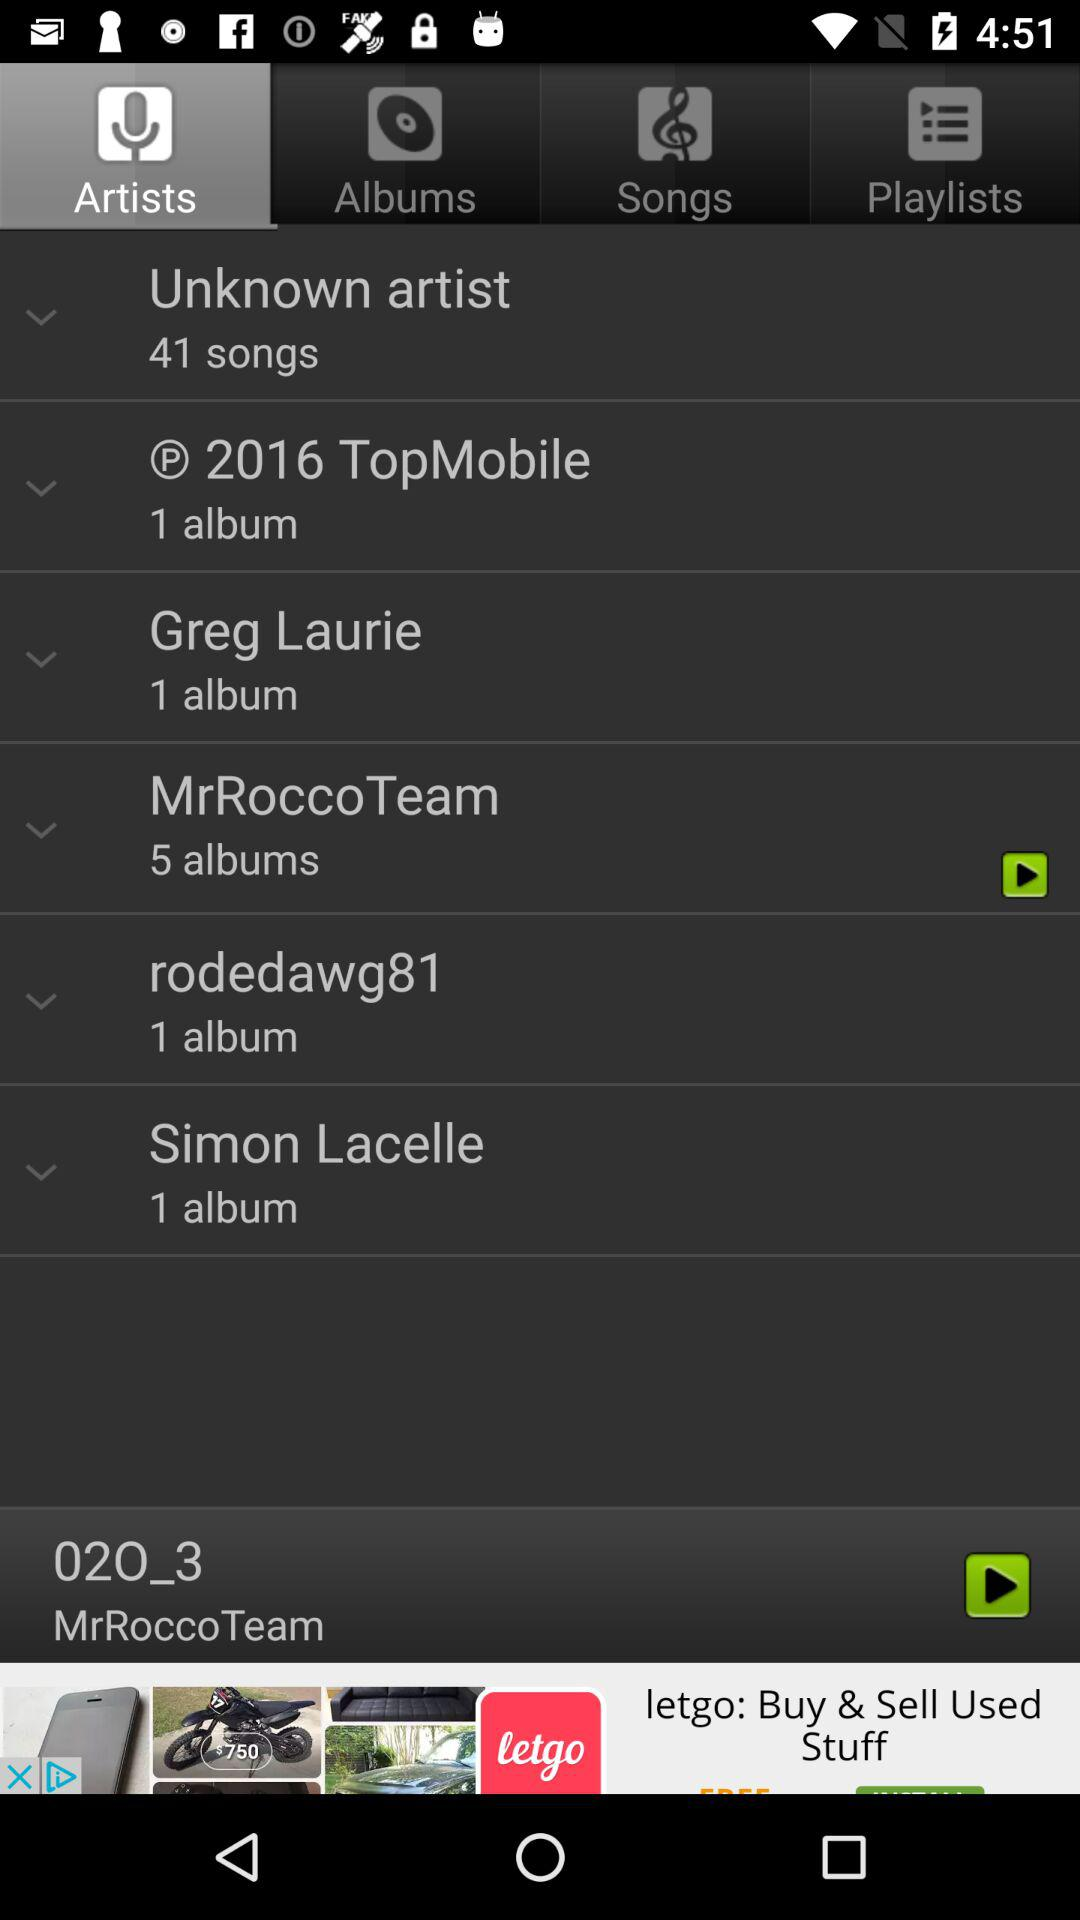How many albums does the "MrRoccoteam" have? "MrRoccoteam" have 5 albums. 